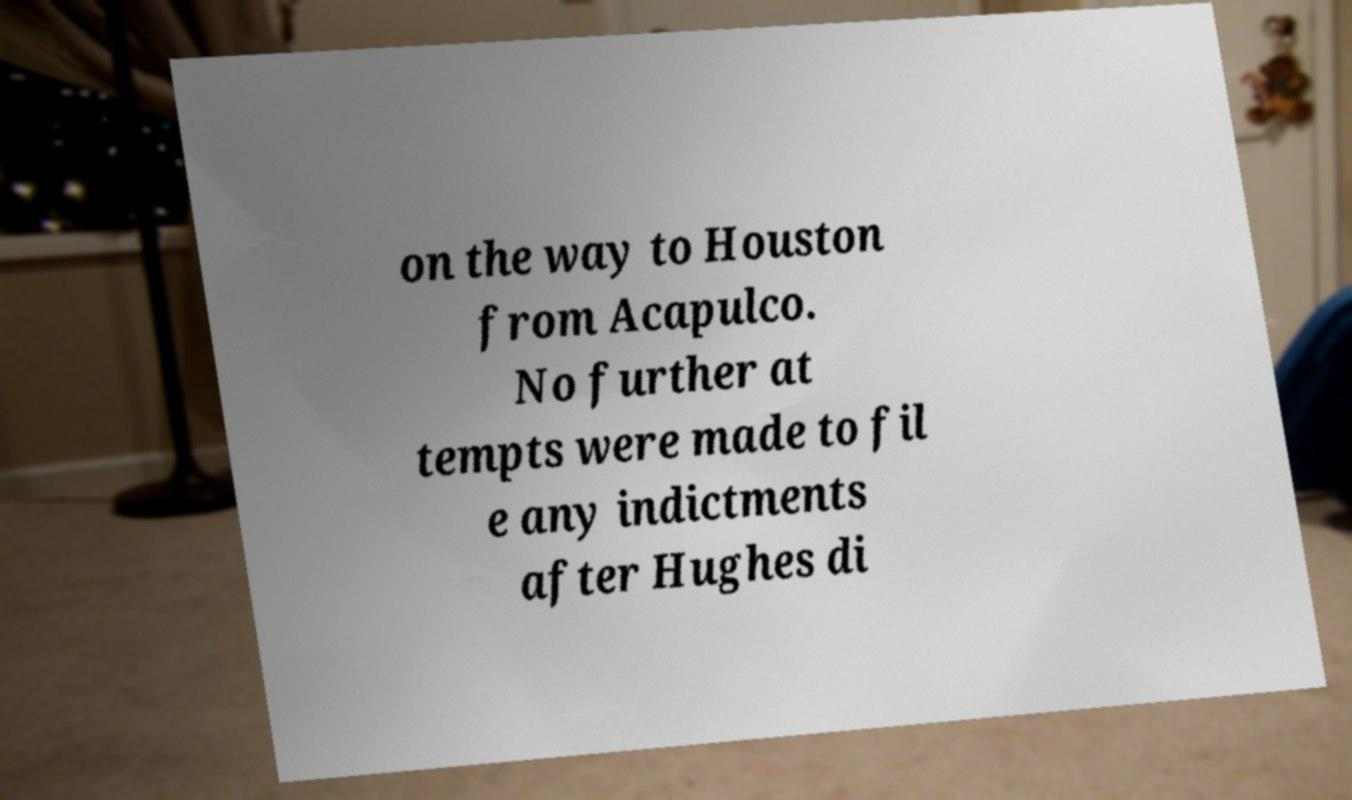For documentation purposes, I need the text within this image transcribed. Could you provide that? on the way to Houston from Acapulco. No further at tempts were made to fil e any indictments after Hughes di 